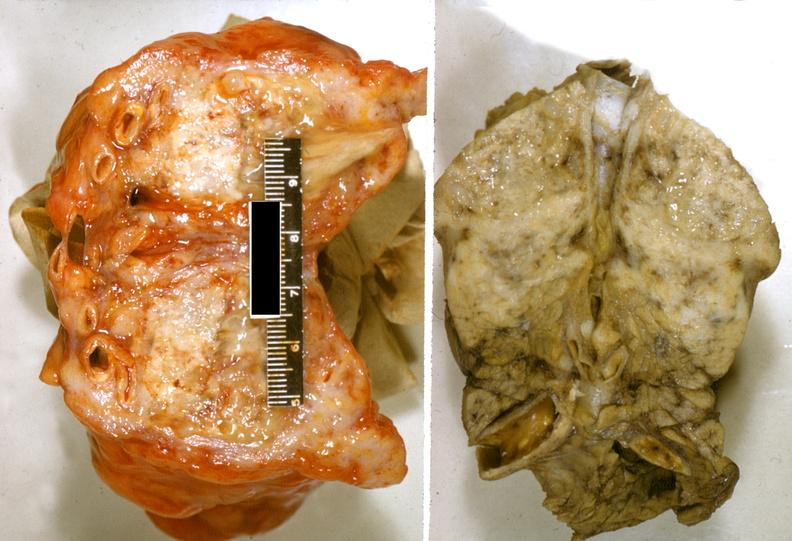what does this image show?
Answer the question using a single word or phrase. Adenocarcinoma 